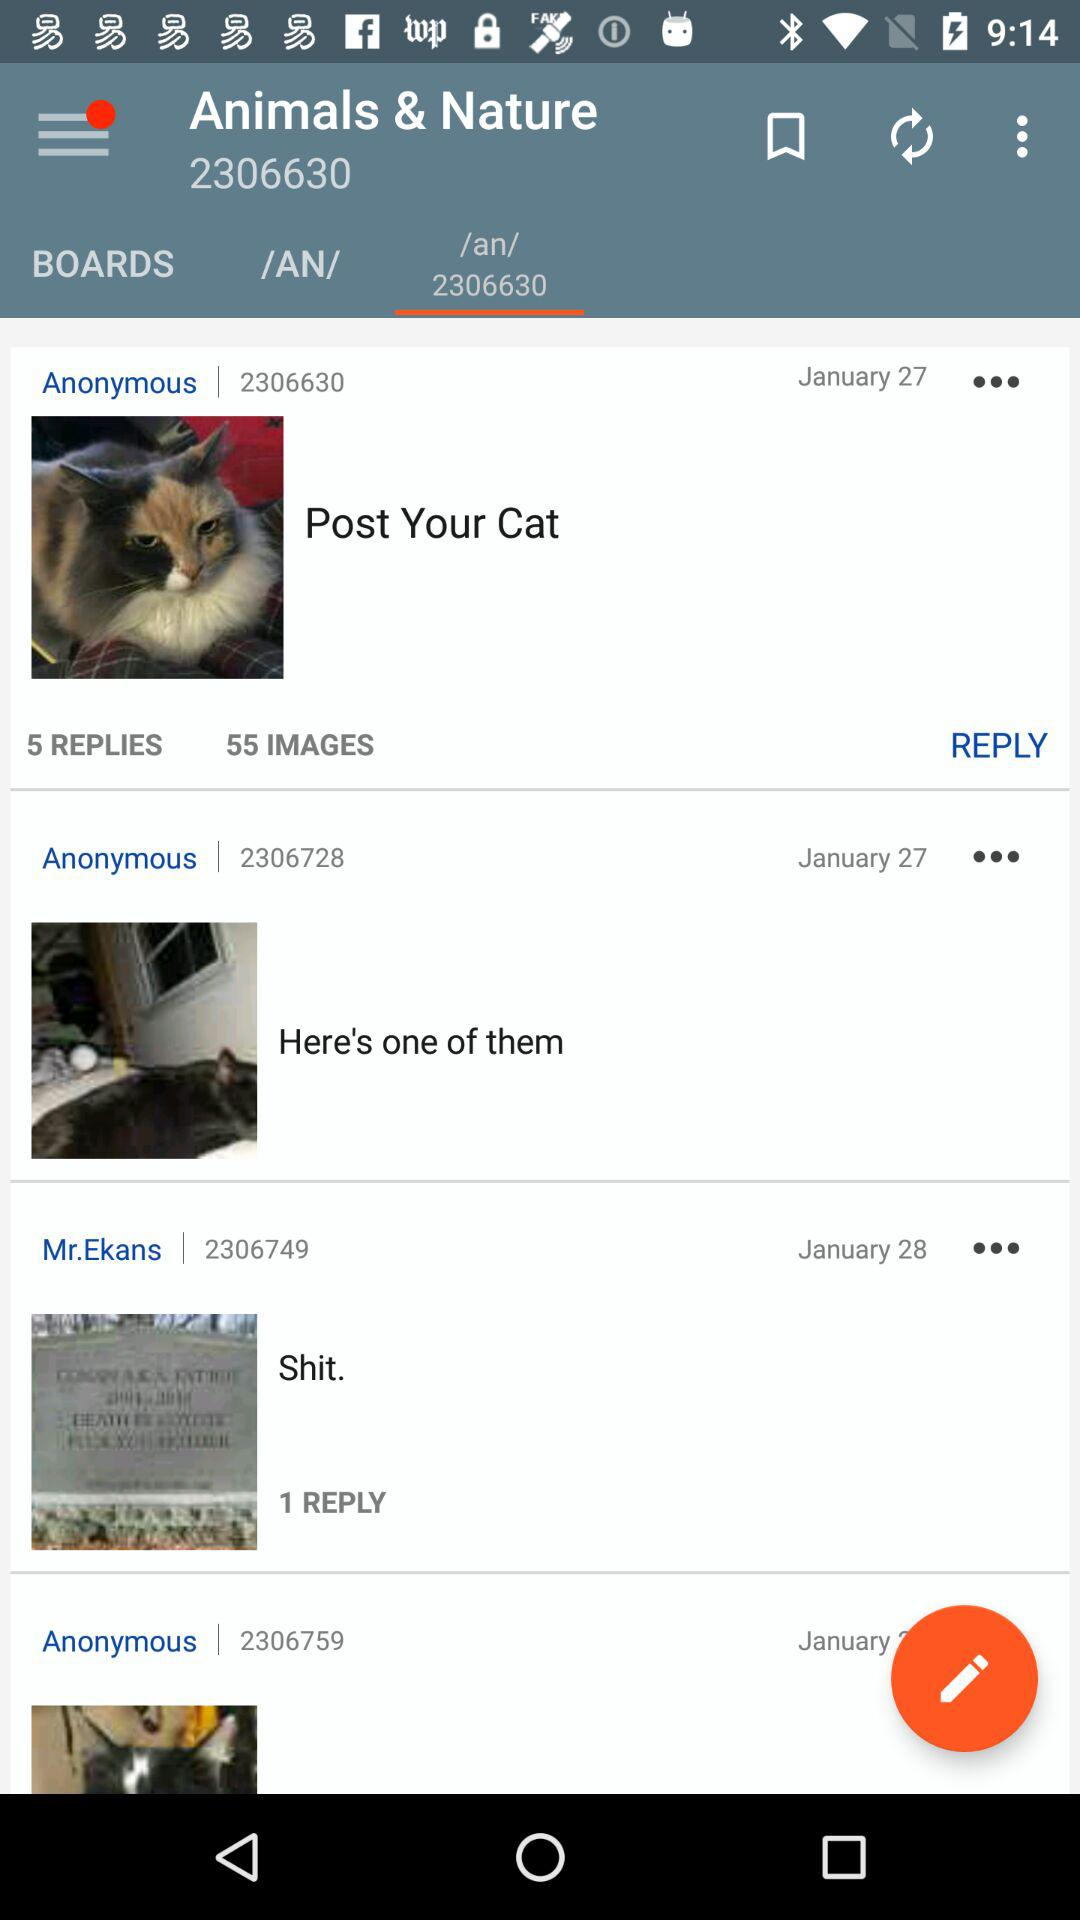What is the total number of images in the post "Post Your Cat"? The total number of images is 55. 